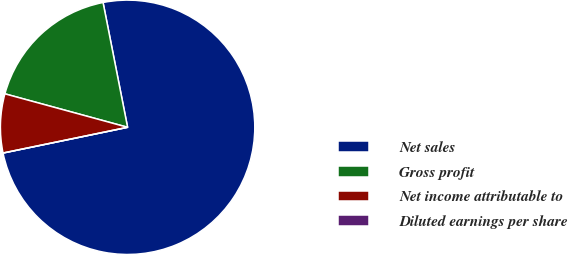Convert chart. <chart><loc_0><loc_0><loc_500><loc_500><pie_chart><fcel>Net sales<fcel>Gross profit<fcel>Net income attributable to<fcel>Diluted earnings per share<nl><fcel>74.84%<fcel>17.67%<fcel>7.48%<fcel>0.0%<nl></chart> 